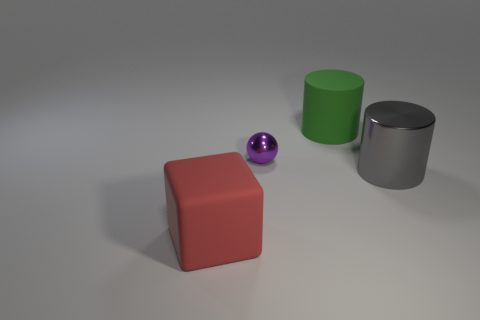Is there any other thing that is the same size as the purple sphere?
Offer a terse response. No. What number of other objects are the same material as the red block?
Give a very brief answer. 1. What is the material of the cube that is the same size as the green matte cylinder?
Ensure brevity in your answer.  Rubber. What shape is the big thing on the right side of the cylinder that is behind the big gray thing?
Offer a terse response. Cylinder. There is a green rubber cylinder; how many big metallic cylinders are on the right side of it?
Ensure brevity in your answer.  1. Do the tiny object and the large cylinder in front of the large green thing have the same material?
Provide a short and direct response. Yes. Is there a matte cube that has the same size as the green cylinder?
Offer a terse response. Yes. Are there an equal number of tiny metallic objects that are to the left of the small ball and tiny yellow shiny balls?
Your answer should be compact. Yes. The gray cylinder has what size?
Your response must be concise. Large. How many purple shiny objects are to the right of the big thing that is left of the large green rubber cylinder?
Offer a terse response. 1. 